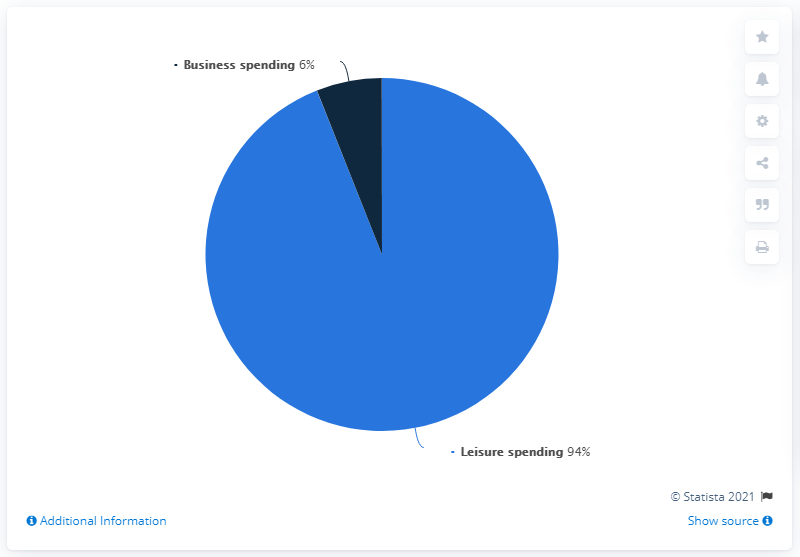List a handful of essential elements in this visual. Business spending has a relatively low percentage compared to other areas of government spending. The difference between leisure and business spending refers to the distinction between how individuals and businesses allocate their expenditure on goods and services. Leisure spending refers to the amount of money spent on non-essential items for personal enjoyment or recreation, while business spending refers to the expenditure on goods and services required for business operations. 